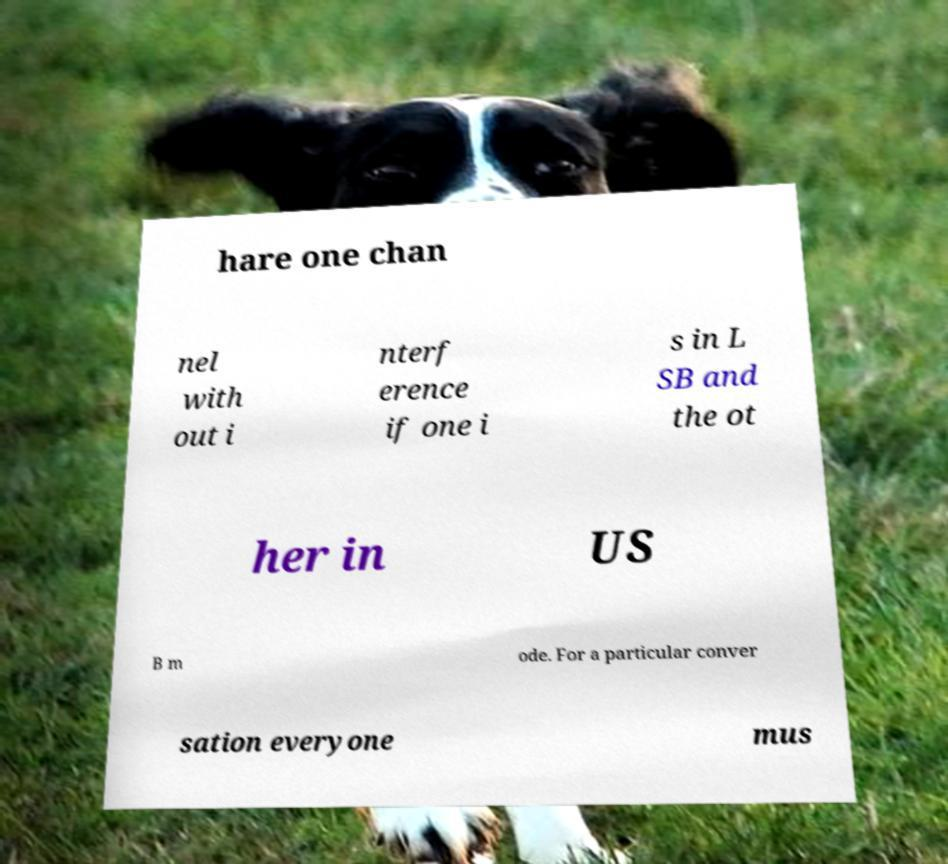Can you accurately transcribe the text from the provided image for me? hare one chan nel with out i nterf erence if one i s in L SB and the ot her in US B m ode. For a particular conver sation everyone mus 